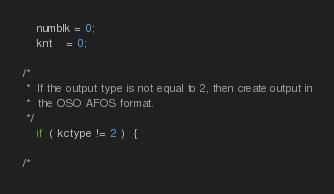Convert code to text. <code><loc_0><loc_0><loc_500><loc_500><_C_>	numblk = 0;
	knt    = 0;

/*
 *	If the output type is not equal to 2, then create output in
 *	the OSO AFOS format.
 */
	if  ( kctype != 2 )  {

/*</code> 